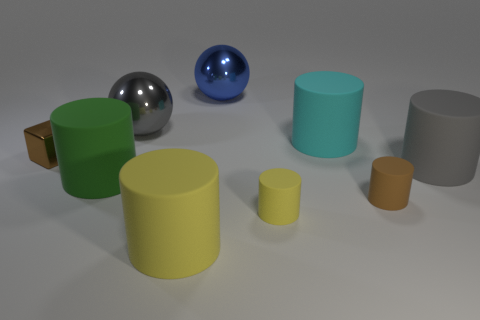Are there any other things that have the same shape as the tiny shiny object?
Your answer should be compact. No. Does the small shiny thing have the same color as the small rubber cylinder that is to the right of the cyan matte cylinder?
Ensure brevity in your answer.  Yes. How many things are either cylinders that are behind the big gray matte cylinder or objects that are on the left side of the gray metallic ball?
Make the answer very short. 3. There is a cyan object that is the same size as the gray cylinder; what is its material?
Provide a succinct answer. Rubber. How many other objects are there of the same material as the big gray ball?
Keep it short and to the point. 2. There is a large thing that is in front of the green matte cylinder; is its shape the same as the large matte thing that is behind the big gray matte object?
Keep it short and to the point. Yes. The matte cylinder in front of the yellow matte cylinder that is on the right side of the yellow rubber cylinder on the left side of the small yellow cylinder is what color?
Keep it short and to the point. Yellow. Is the number of small brown shiny things less than the number of brown things?
Ensure brevity in your answer.  Yes. What is the color of the matte thing that is to the right of the cyan cylinder and behind the brown rubber cylinder?
Offer a very short reply. Gray. There is a big cyan thing that is the same shape as the large yellow thing; what material is it?
Provide a succinct answer. Rubber. 